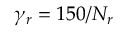Convert formula to latex. <formula><loc_0><loc_0><loc_500><loc_500>\gamma _ { r } = 1 5 0 / N _ { r }</formula> 